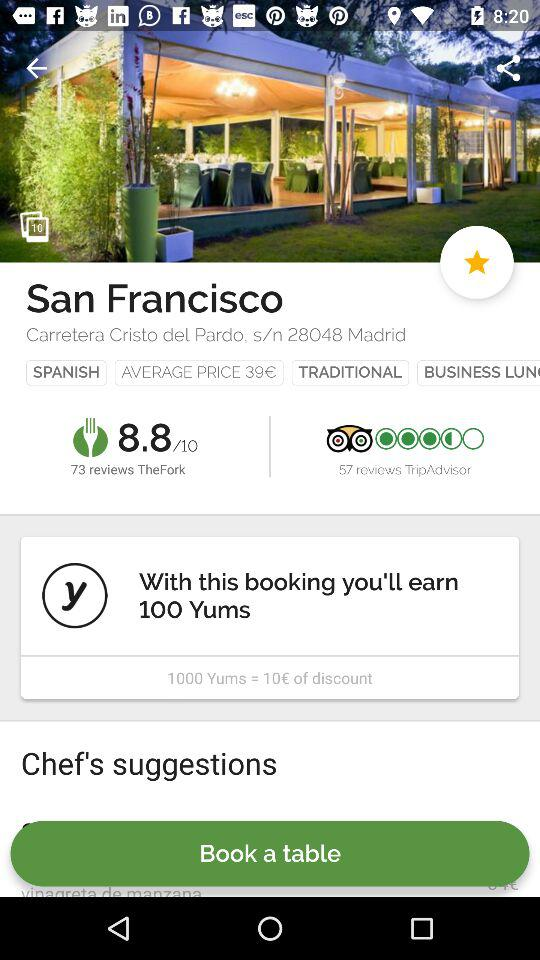What is the total number of reviewers for "TheFork"? The total number of reviewers is 73. 